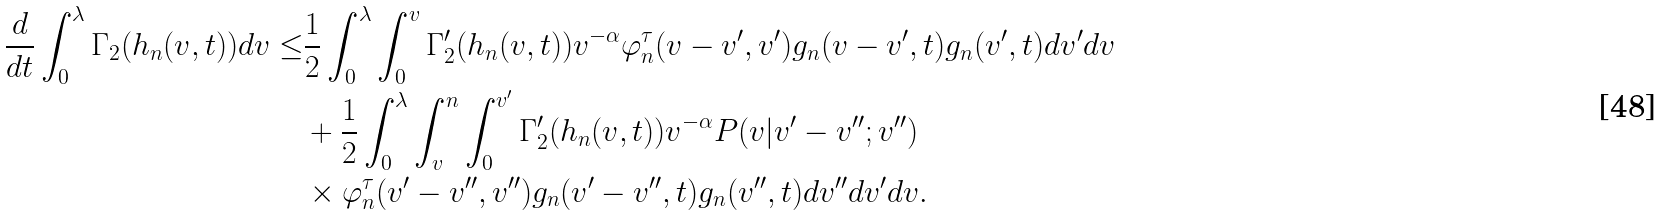Convert formula to latex. <formula><loc_0><loc_0><loc_500><loc_500>\frac { d } { d t } \int _ { 0 } ^ { \lambda } \Gamma _ { 2 } ( h _ { n } ( v , t ) ) d v \leq & \frac { 1 } { 2 } \int _ { 0 } ^ { \lambda } \int _ { 0 } ^ { v } \Gamma _ { 2 } ^ { \prime } ( h _ { n } ( v , t ) ) v ^ { - \alpha } \varphi _ { n } ^ { \tau } ( v - v ^ { \prime } , v ^ { \prime } ) g _ { n } ( v - v ^ { \prime } , t ) g _ { n } ( v ^ { \prime } , t ) d v ^ { \prime } d v \\ & + \frac { 1 } { 2 } \int _ { 0 } ^ { \lambda } \int _ { v } ^ { n } \int _ { 0 } ^ { v ^ { \prime } } \Gamma _ { 2 } ^ { \prime } ( h _ { n } ( v , t ) ) v ^ { - \alpha } P ( v | v ^ { \prime } - v ^ { \prime \prime } ; v ^ { \prime \prime } ) \\ & \times \varphi _ { n } ^ { \tau } ( v ^ { \prime } - v ^ { \prime \prime } , v ^ { \prime \prime } ) g _ { n } ( v ^ { \prime } - v ^ { \prime \prime } , t ) g _ { n } ( v ^ { \prime \prime } , t ) d v ^ { \prime \prime } d v ^ { \prime } d v .</formula> 